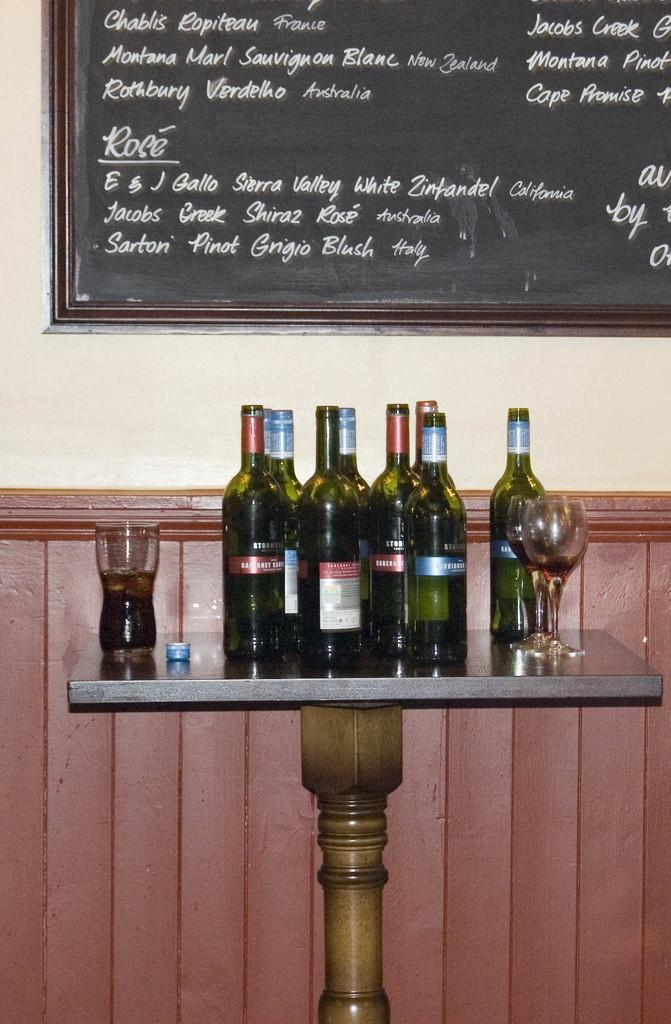<image>
Create a compact narrative representing the image presented. A menu with different wine choices, including Rose, is on a blackboard above a table with wine bottles. 